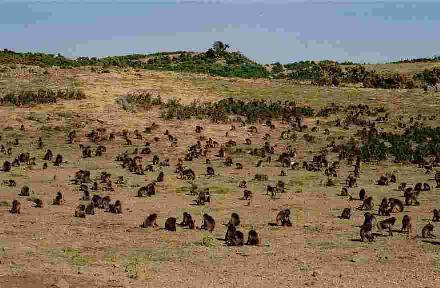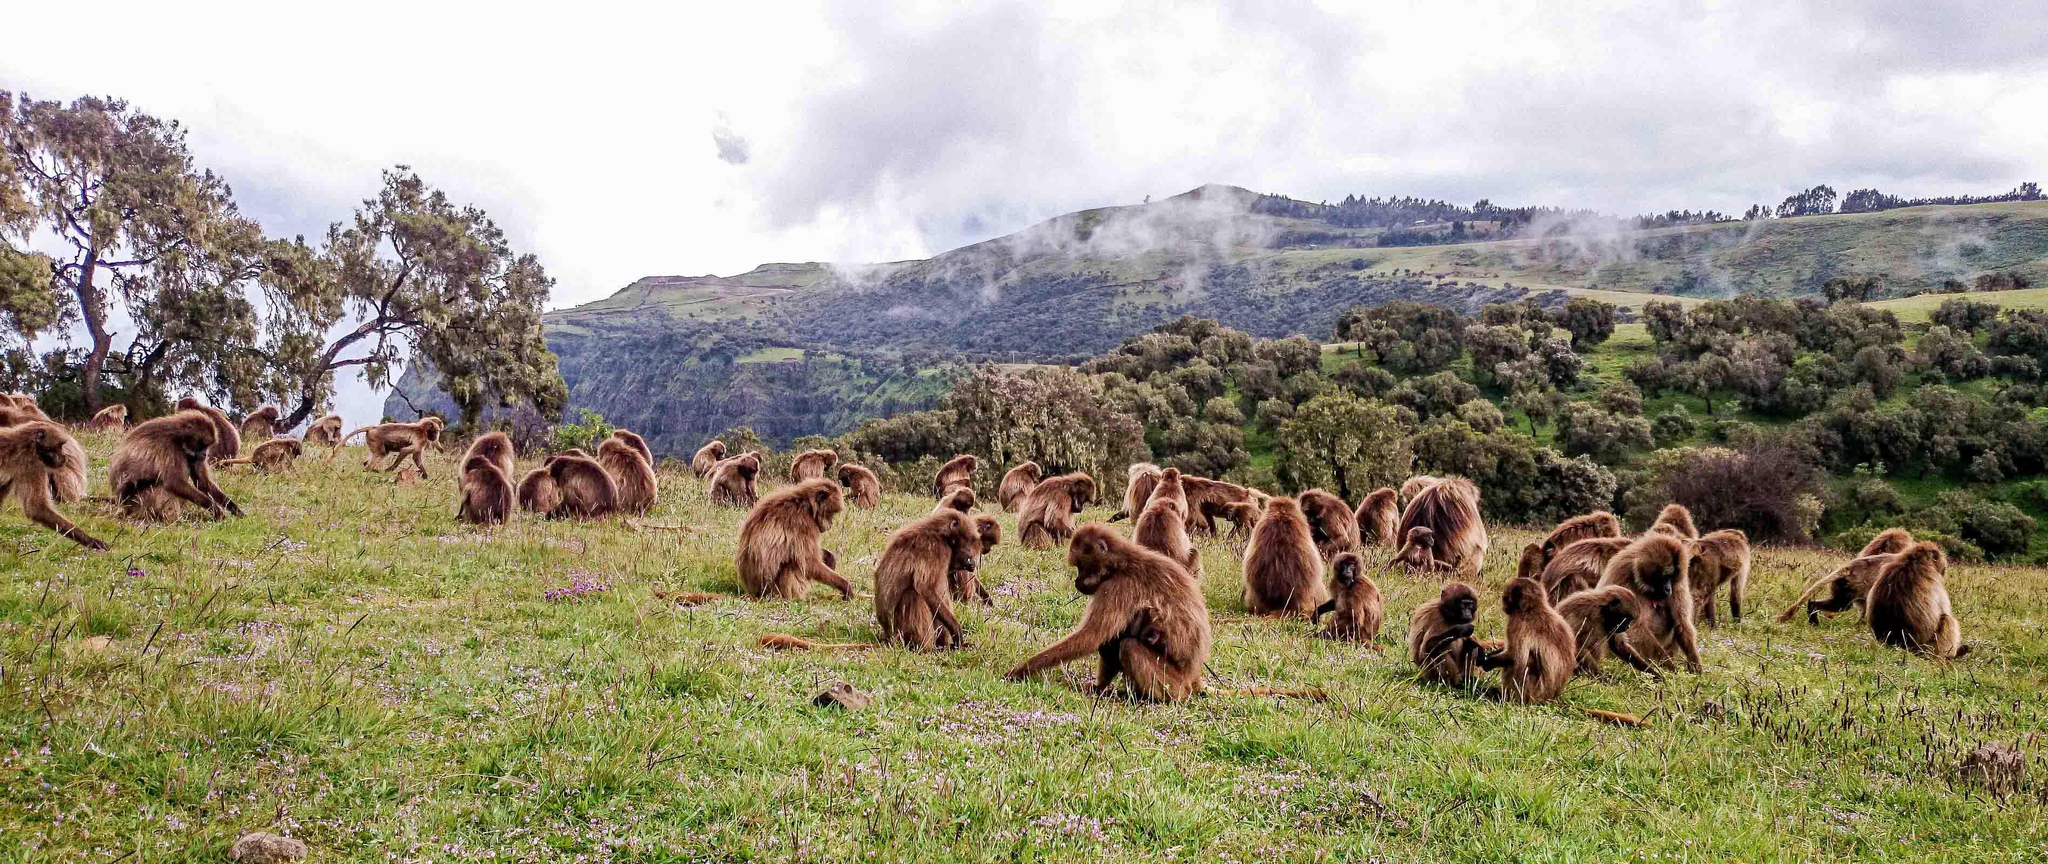The first image is the image on the left, the second image is the image on the right. For the images displayed, is the sentence "There are two groups of monkeys in the center of the images." factually correct? Answer yes or no. Yes. 